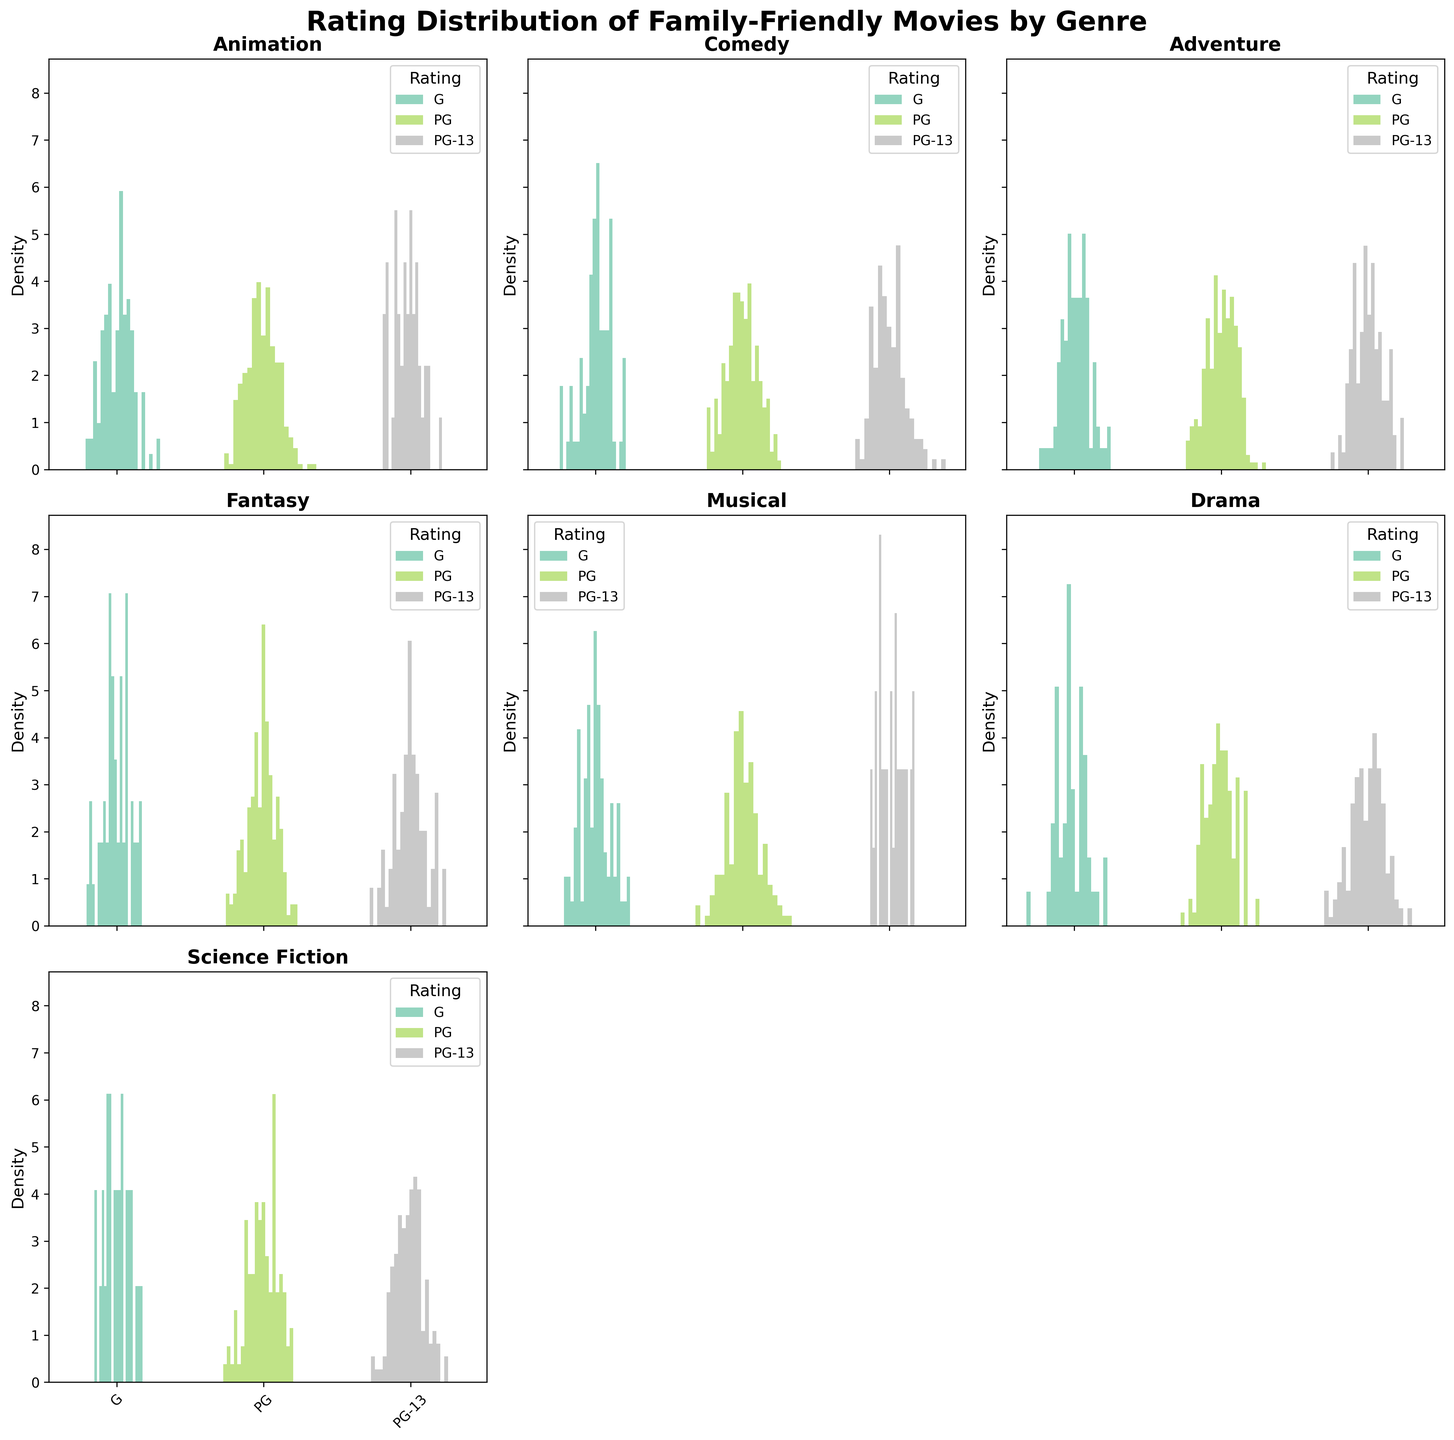What is the title of the figure? The title of the figure is displayed at the top of the figure.
Answer: Rating Distribution of Family-Friendly Movies by Genre How many genres are presented in the figure? Count the number of subplots, each subplot represents a different genre. There are 7 subplots.
Answer: 7 Which genre has the highest density for PG-rated movies? Look for the subplot with the tallest density peak for PG-rated movies, indicated in a specific color that is consistently used across all genres. In this case, Animation has the highest density for PG-rated movies.
Answer: Animation How many ratings are there in each genre? Each subplot has the same number of x-axis ticks representing different ratings. Each genre has three ratings (G, PG, PG-13).
Answer: 3 Which genre has the lowest density for G-rated movies? Identify the subplot with the shortest density peak for G-rated movies. Science Fiction has the lowest density for G-rated movies.
Answer: Science Fiction Compare the density of PG-13 rated movies in Comedy and Drama genres. Which one is higher? Look at the density peaks for PG-13 rated movies in the Comedy and Drama subplots. The subplot for Comedy has a smaller density peak compared to Drama for PG-13 rated movies.
Answer: Drama What is the color used for PG-rated movies in the density plots? Identify the color consistently used for PG-rated movies across all subplots. Matplotlib's default color mapping for specific categories is visible throughout the figure.
Answer: A specific color (e.g., a shade of green based on the color map from `plt.cm.Set2` but expressed here in plain terms) In which genre is the distribution of movie ratings the most evenly spread? Analyze each subplot to see which one has more balanced density peaks across all three ratings (G, PG, PG-13). Adventure seems to have a relatively even distribution across the ratings.
Answer: Adventure How does the density of G-rated movies in Musical compare to Animation? Compare the height of the density peaks for G-rated movies in the Musical and Animation subplots. Animation has a higher density peak for G-rated movies than Musical.
Answer: Animation Which genre has the most prominent density peak overall, and for which rating? Look for the subplot with the highest peak overall and identify its rating. Animation has the most prominent density peak for PG-rated movies.
Answer: Animation for PG 